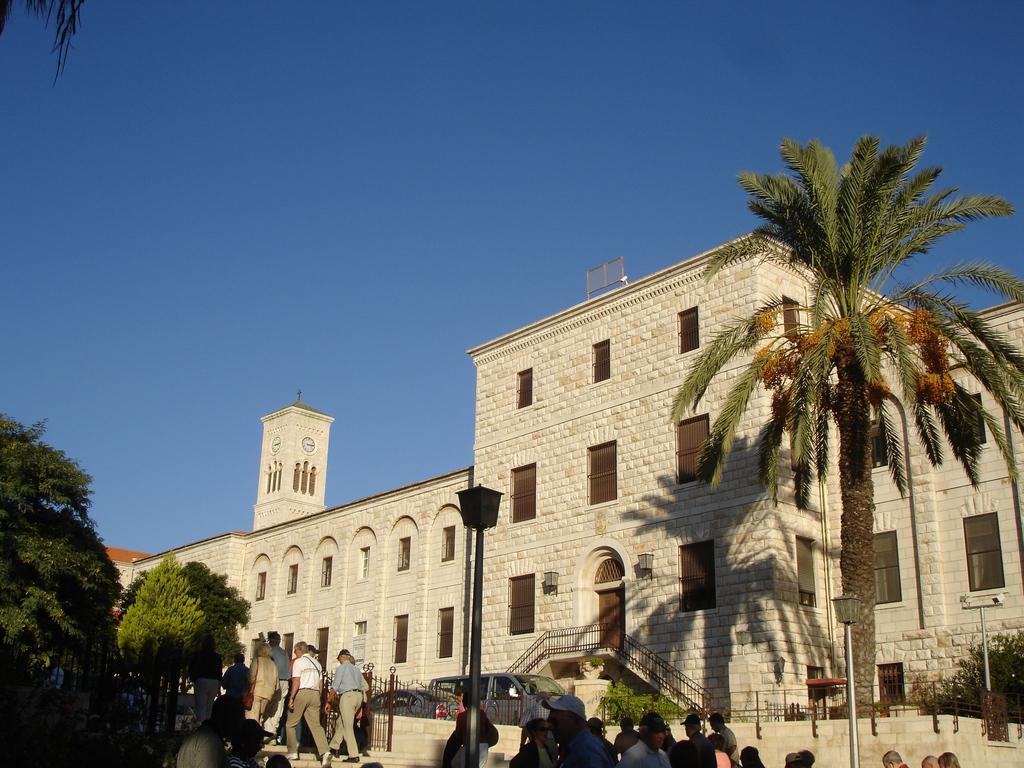Could you give a brief overview of what you see in this image? In this image I can see a group of people walking in front of white building and also I can see more number of people standing there. I can see number of trees and clear blue sky. I can also see a clock on the building and a street light in front of it. I can also see number of vehicles in front of the entrance gate of the building. 